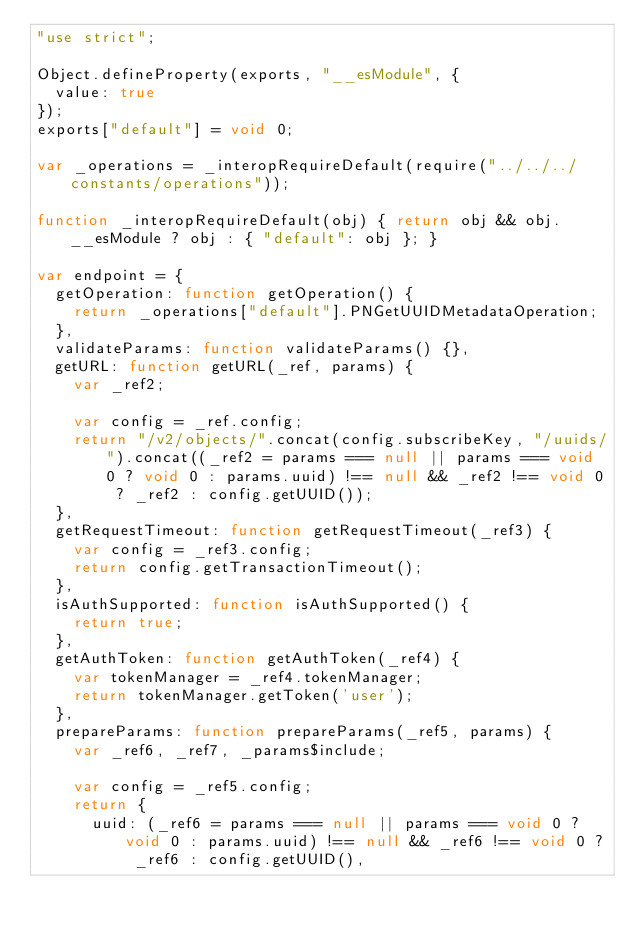<code> <loc_0><loc_0><loc_500><loc_500><_JavaScript_>"use strict";

Object.defineProperty(exports, "__esModule", {
  value: true
});
exports["default"] = void 0;

var _operations = _interopRequireDefault(require("../../../constants/operations"));

function _interopRequireDefault(obj) { return obj && obj.__esModule ? obj : { "default": obj }; }

var endpoint = {
  getOperation: function getOperation() {
    return _operations["default"].PNGetUUIDMetadataOperation;
  },
  validateParams: function validateParams() {},
  getURL: function getURL(_ref, params) {
    var _ref2;

    var config = _ref.config;
    return "/v2/objects/".concat(config.subscribeKey, "/uuids/").concat((_ref2 = params === null || params === void 0 ? void 0 : params.uuid) !== null && _ref2 !== void 0 ? _ref2 : config.getUUID());
  },
  getRequestTimeout: function getRequestTimeout(_ref3) {
    var config = _ref3.config;
    return config.getTransactionTimeout();
  },
  isAuthSupported: function isAuthSupported() {
    return true;
  },
  getAuthToken: function getAuthToken(_ref4) {
    var tokenManager = _ref4.tokenManager;
    return tokenManager.getToken('user');
  },
  prepareParams: function prepareParams(_ref5, params) {
    var _ref6, _ref7, _params$include;

    var config = _ref5.config;
    return {
      uuid: (_ref6 = params === null || params === void 0 ? void 0 : params.uuid) !== null && _ref6 !== void 0 ? _ref6 : config.getUUID(),</code> 